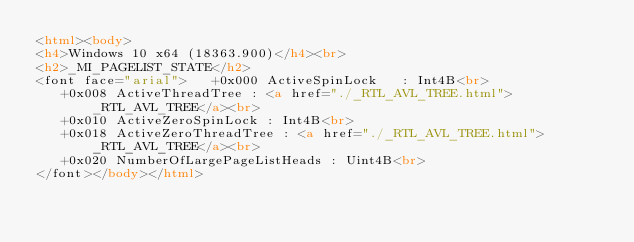Convert code to text. <code><loc_0><loc_0><loc_500><loc_500><_HTML_><html><body>
<h4>Windows 10 x64 (18363.900)</h4><br>
<h2>_MI_PAGELIST_STATE</h2>
<font face="arial">   +0x000 ActiveSpinLock   : Int4B<br>
   +0x008 ActiveThreadTree : <a href="./_RTL_AVL_TREE.html">_RTL_AVL_TREE</a><br>
   +0x010 ActiveZeroSpinLock : Int4B<br>
   +0x018 ActiveZeroThreadTree : <a href="./_RTL_AVL_TREE.html">_RTL_AVL_TREE</a><br>
   +0x020 NumberOfLargePageListHeads : Uint4B<br>
</font></body></html></code> 